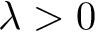<formula> <loc_0><loc_0><loc_500><loc_500>\lambda > 0</formula> 